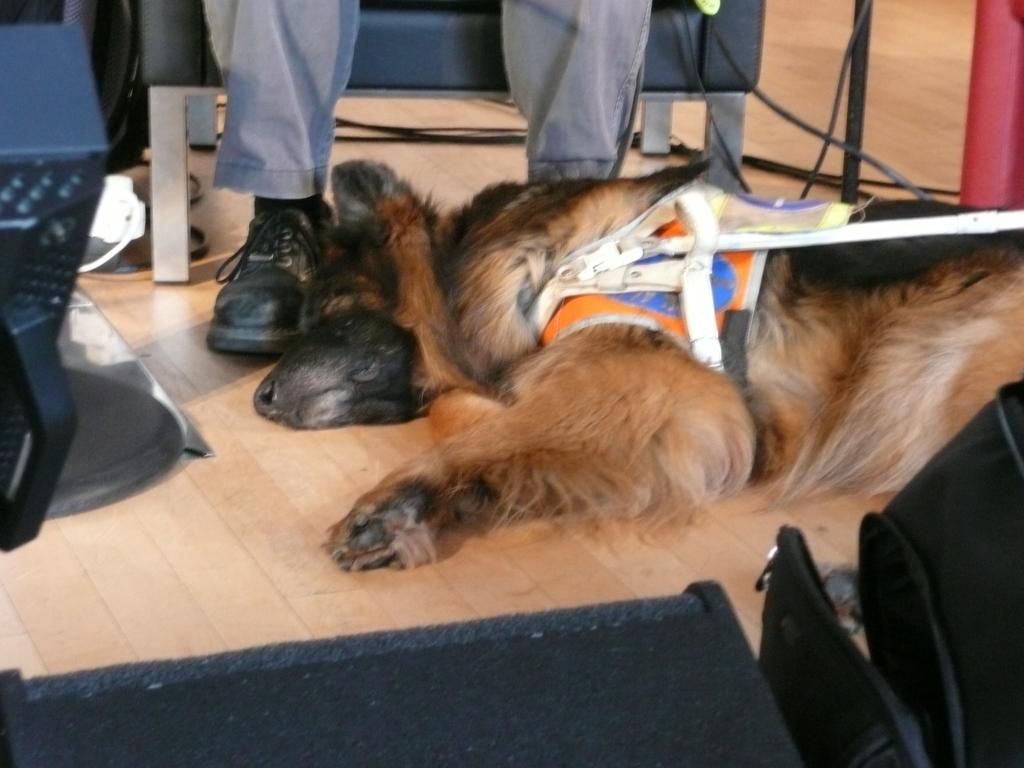What animal can be seen in the image? There is a dog in the image. What is the dog doing in the image? The dog is lying on the ground. What colors can be seen on the dog? The dog is black and brown in color. What type of furniture is visible in the image? There are chairs at the bottom of the image. Can you describe the person in the image? There is a person sitting on a chair at the top of the image. What type of throat problem does the dog have in the image? There is no indication of any throat problem in the image; the dog is simply lying on the ground. 